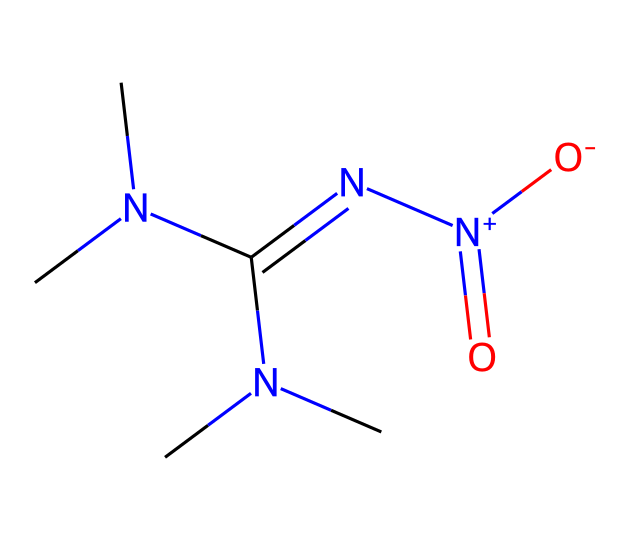how many nitrogen atoms are present in this chemical? By examining the SMILES representation, we can count the nitrogen (N) atoms. In the structure, there are three nitrogen atoms indicated.
Answer: three what type of chemical is this compound? The presence of a carbene center indicates that it belongs to the class of carbenes. The structure contains a C atom with two R groups (the two N(CH3)2 arm groups).
Answer: carbene how many carbon atoms are found in the structure? Counting the carbon (C) atoms in the SMILES, we note that there are a total of four carbon atoms present.
Answer: four does this compound contain any charged groups? In the structure, we observe that there is a positively charged nitrogen ([N+]) with an attached anionic oxygen ([O-]), indicating that this compound does indeed contain charged groups.
Answer: yes what is the significance of the nitro group in this compound? The nitro group (N[O-] = O) is known for its strong oxidizing properties, which can enhance flame retardant characteristics, making it beneficial in protective gear for extreme sports.
Answer: flame retardant what is the molecular formula based on the SMILES representation? The molecular formula can be derived from counting each type of atom in the SMILES: C4H10N4O2. Therefore, the molecular formula is C4H10N4O2.
Answer: C4H10N4O2 how many double bonds are present in the chemical structure? Observing the SMILES representation, there is one double bond indicated between nitrogen and carbon, specifically at C(=N). Hence, there is one double bond in this chemical.
Answer: one 